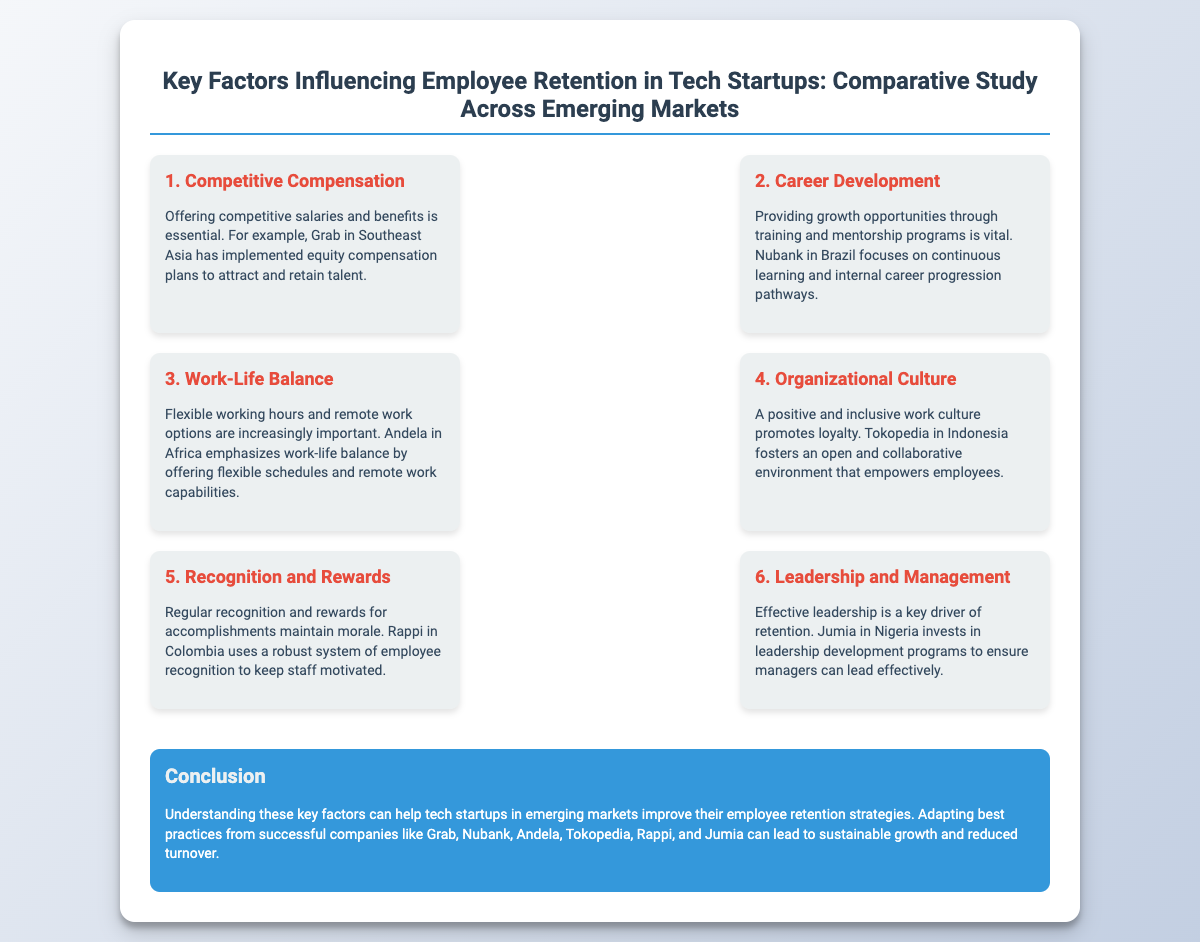What is the main focus of the study? The study focuses on the key factors influencing employee retention in tech startups across emerging markets.
Answer: Employee retention Which startup offers equity compensation plans? The document mentions Grab in Southeast Asia implementing equity compensation plans to attract and retain talent.
Answer: Grab What is emphasized by Andela regarding work-life balance? Andela emphasizes offering flexible schedules and remote work capabilities to promote work-life balance.
Answer: Flexible schedules What does Nubank focus on for career development? Nubank focuses on continuous learning and internal career progression pathways.
Answer: Continuous learning Which company invests in leadership development programs? Jumia in Nigeria invests in leadership development programs to ensure effective management.
Answer: Jumia What factor is crucial for organizational loyalty according to the slide? A positive and inclusive work culture is identified as crucial for promoting loyalty.
Answer: Organizational culture Which country is mentioned in relation to Rappi's employee recognition system? Rappi is mentioned in the context of Colombia for its robust employee recognition system.
Answer: Colombia What is the conclusion of the study about employee retention strategies? The conclusion suggests that understanding key factors can improve employee retention strategies in tech startups.
Answer: Improve retention strategies What color is associated with the conclusion section? The conclusion section uses a blue color background.
Answer: Blue How many sections are there discussing different factors influencing employee retention? There are six sections discussing various factors influencing employee retention.
Answer: Six 